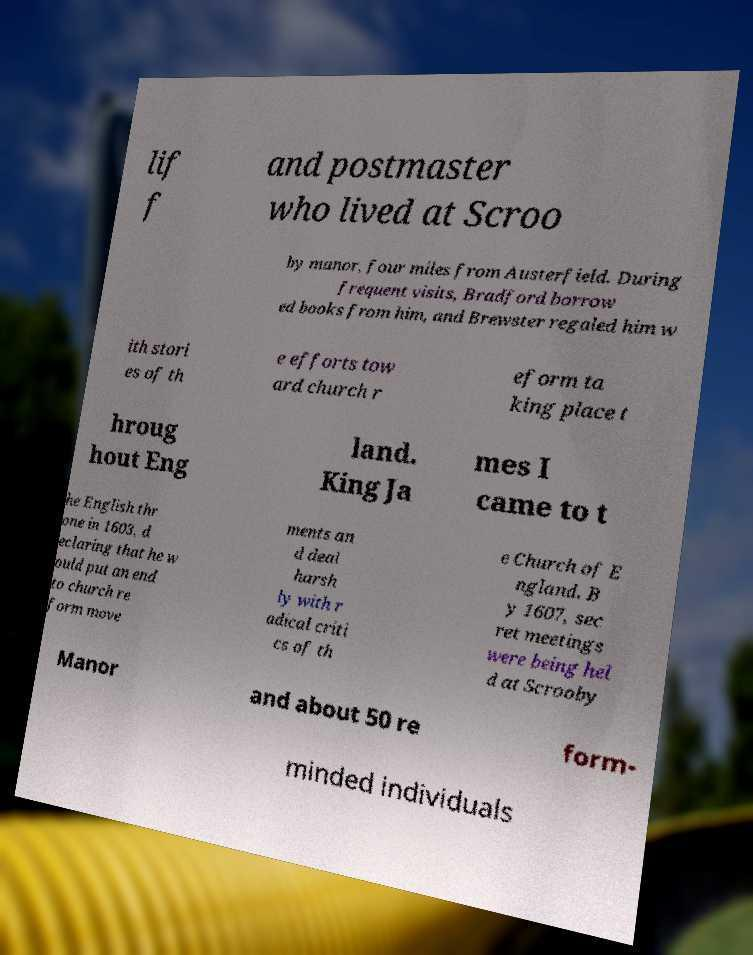Could you assist in decoding the text presented in this image and type it out clearly? lif f and postmaster who lived at Scroo by manor, four miles from Austerfield. During frequent visits, Bradford borrow ed books from him, and Brewster regaled him w ith stori es of th e efforts tow ard church r eform ta king place t hroug hout Eng land. King Ja mes I came to t he English thr one in 1603, d eclaring that he w ould put an end to church re form move ments an d deal harsh ly with r adical criti cs of th e Church of E ngland. B y 1607, sec ret meetings were being hel d at Scrooby Manor and about 50 re form- minded individuals 